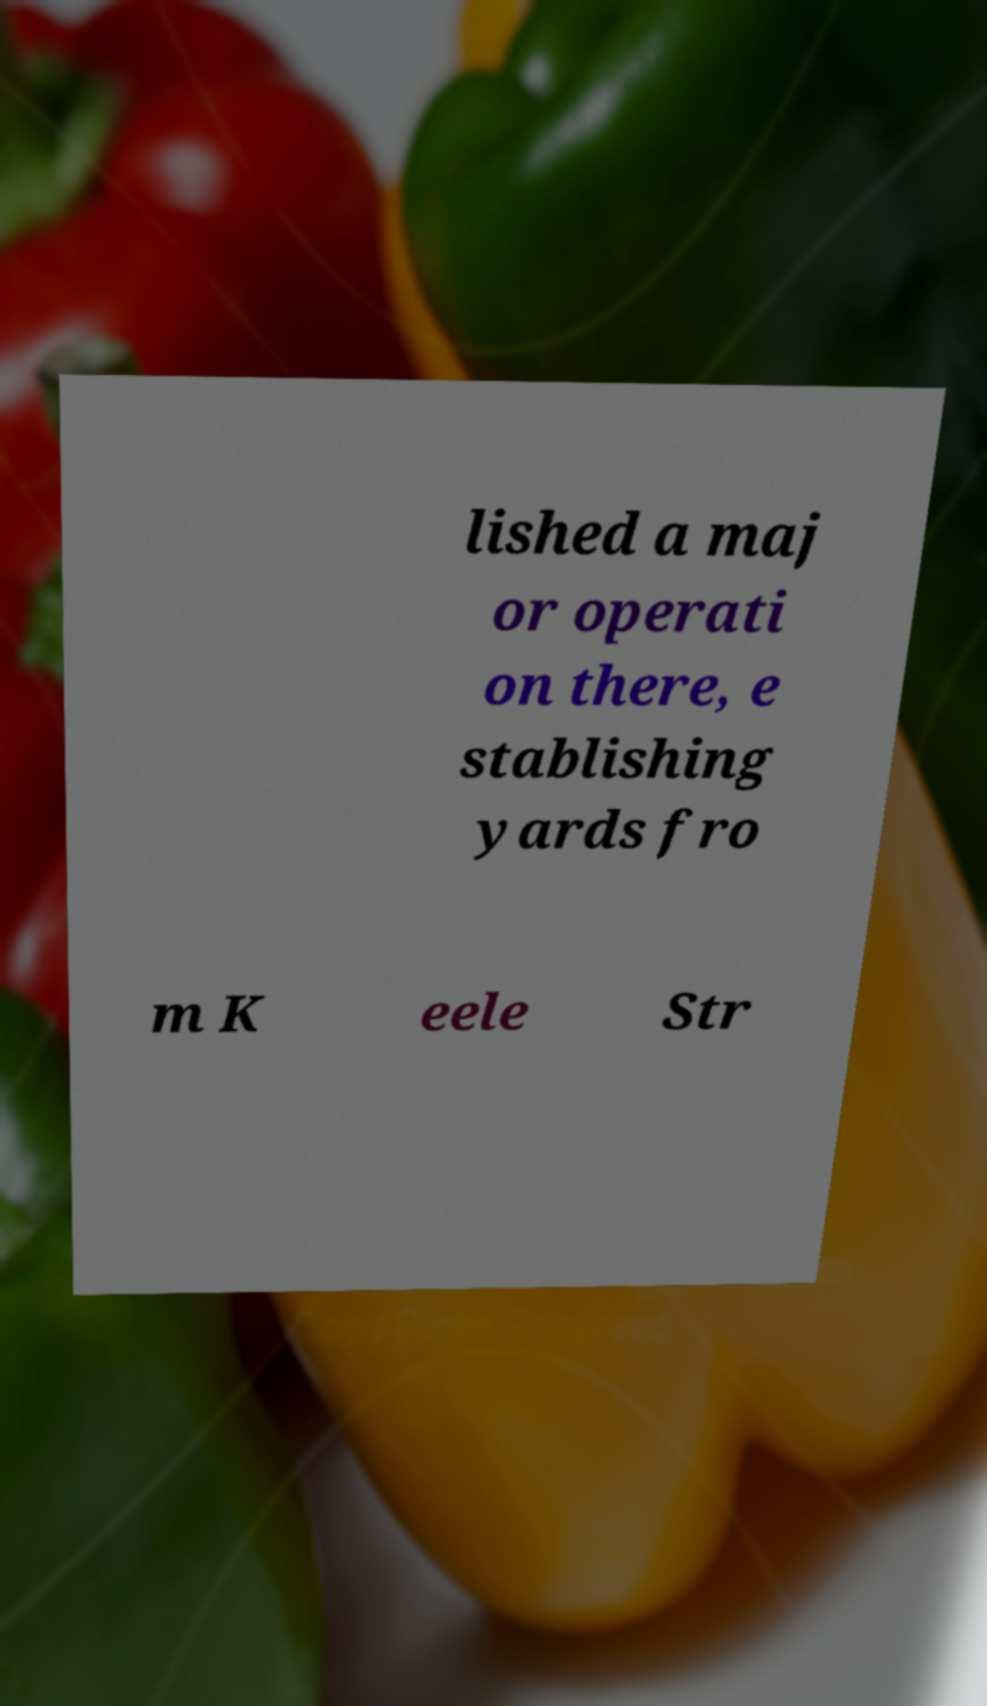Could you extract and type out the text from this image? lished a maj or operati on there, e stablishing yards fro m K eele Str 